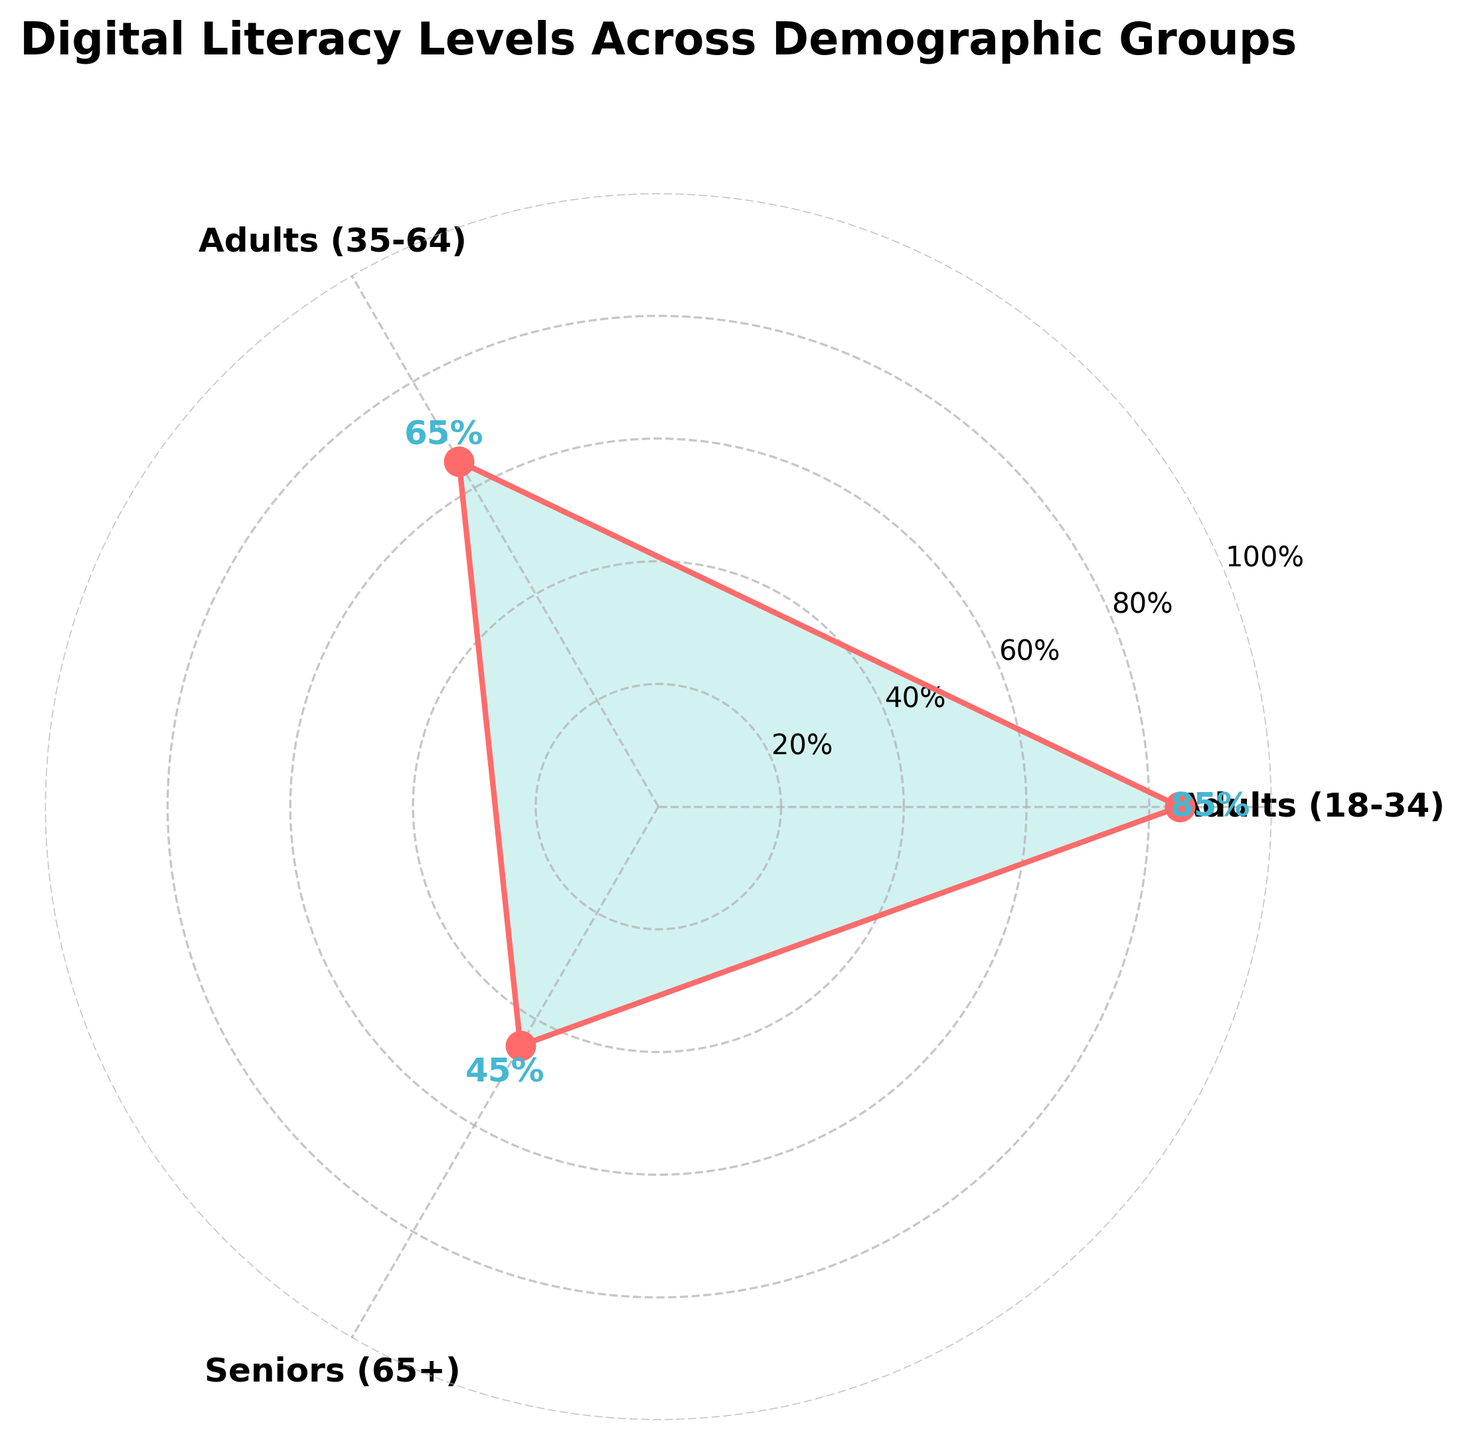What is the title of the figure? The title of the figure is located at the top and is usually the largest text element in the chart. It provides a brief description of the data represented.
Answer: Digital Literacy Levels Across Demographic Groups How many demographic groups are displayed on the rose chart? In a rose chart, the number of demographic groups is indicated by the distinct segments or categories. Each segment corresponds to a group name.
Answer: Three Which demographic group has the highest digital literacy level? To determine this, compare the values or the lengths of the segments that extend from the center of the chart for each group. The one with the longest segment represents the highest level.
Answer: Adults (18-34) What is the digital literacy level difference between the Adults (18-34) and Seniors (65+) groups? Subtract the digital literacy level of the Seniors (65+) group from that of the Adults (18-34) group. The values are 85 for Adults (18-34) and 45 for Seniors (65+). 85 - 45 = 40.
Answer: 40 What are the digital literacy levels for each demographic group displayed? Look at the specific numeric values annotated at the top of each segment for each group in the chart.
Answer: 85 for Adults (18-34), 65 for Adults (35-64), 45 for Seniors (65+) Which two demographic groups have the most similar digital literacy levels? To answer this, compare the digital literacy levels of each group and identify the two groups with the smallest difference in their values.
Answer: Adults (18-34) and Youth (Under 18) What is the average digital literacy level across the displayed demographic groups? The average is calculated by summing the digital literacy levels of the groups and dividing by the number of groups. (85 + 65 + 45) / 3 = 195 / 3 = 65
Answer: 65 Describe the overall trend in digital literacy levels across the demographic groups. To identify the trend, observe the relative heights and angles of the segments representing each group's digital literacy levels, noting any patterns or noticeable increases/decreases among the groups.
Answer: Generally decreases with age 